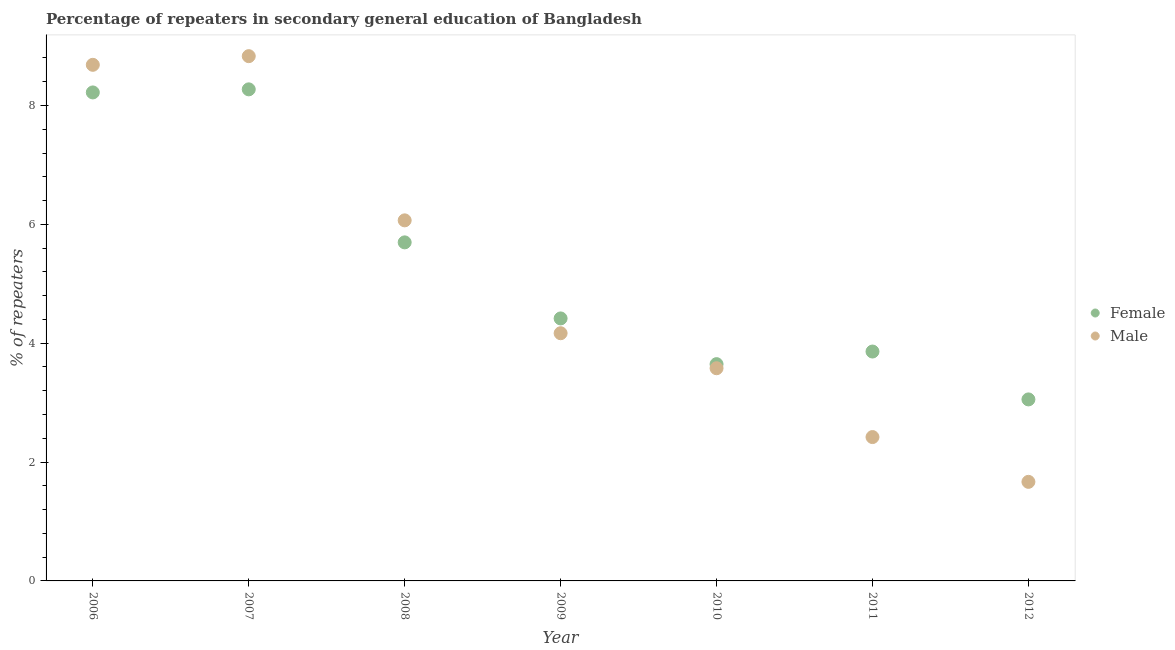What is the percentage of male repeaters in 2006?
Give a very brief answer. 8.68. Across all years, what is the maximum percentage of female repeaters?
Provide a succinct answer. 8.27. Across all years, what is the minimum percentage of female repeaters?
Offer a terse response. 3.05. In which year was the percentage of female repeaters minimum?
Make the answer very short. 2012. What is the total percentage of female repeaters in the graph?
Offer a terse response. 37.17. What is the difference between the percentage of male repeaters in 2007 and that in 2008?
Your answer should be very brief. 2.76. What is the difference between the percentage of male repeaters in 2010 and the percentage of female repeaters in 2008?
Offer a terse response. -2.12. What is the average percentage of male repeaters per year?
Your answer should be very brief. 5.06. In the year 2010, what is the difference between the percentage of female repeaters and percentage of male repeaters?
Your response must be concise. 0.07. In how many years, is the percentage of female repeaters greater than 4.8 %?
Your answer should be very brief. 3. What is the ratio of the percentage of female repeaters in 2007 to that in 2009?
Offer a very short reply. 1.87. Is the percentage of male repeaters in 2007 less than that in 2008?
Keep it short and to the point. No. What is the difference between the highest and the second highest percentage of male repeaters?
Your response must be concise. 0.15. What is the difference between the highest and the lowest percentage of male repeaters?
Your answer should be very brief. 7.16. In how many years, is the percentage of male repeaters greater than the average percentage of male repeaters taken over all years?
Your response must be concise. 3. How many years are there in the graph?
Ensure brevity in your answer.  7. What is the difference between two consecutive major ticks on the Y-axis?
Provide a succinct answer. 2. Are the values on the major ticks of Y-axis written in scientific E-notation?
Your answer should be compact. No. Does the graph contain grids?
Ensure brevity in your answer.  No. How many legend labels are there?
Offer a very short reply. 2. What is the title of the graph?
Make the answer very short. Percentage of repeaters in secondary general education of Bangladesh. What is the label or title of the Y-axis?
Make the answer very short. % of repeaters. What is the % of repeaters in Female in 2006?
Your response must be concise. 8.22. What is the % of repeaters in Male in 2006?
Provide a succinct answer. 8.68. What is the % of repeaters of Female in 2007?
Provide a short and direct response. 8.27. What is the % of repeaters of Male in 2007?
Ensure brevity in your answer.  8.83. What is the % of repeaters in Female in 2008?
Keep it short and to the point. 5.7. What is the % of repeaters in Male in 2008?
Ensure brevity in your answer.  6.07. What is the % of repeaters in Female in 2009?
Your answer should be compact. 4.42. What is the % of repeaters of Male in 2009?
Provide a succinct answer. 4.17. What is the % of repeaters of Female in 2010?
Make the answer very short. 3.65. What is the % of repeaters in Male in 2010?
Offer a terse response. 3.58. What is the % of repeaters of Female in 2011?
Keep it short and to the point. 3.86. What is the % of repeaters of Male in 2011?
Your answer should be compact. 2.42. What is the % of repeaters in Female in 2012?
Your answer should be very brief. 3.05. What is the % of repeaters of Male in 2012?
Ensure brevity in your answer.  1.67. Across all years, what is the maximum % of repeaters in Female?
Provide a short and direct response. 8.27. Across all years, what is the maximum % of repeaters in Male?
Your answer should be very brief. 8.83. Across all years, what is the minimum % of repeaters of Female?
Ensure brevity in your answer.  3.05. Across all years, what is the minimum % of repeaters in Male?
Your answer should be very brief. 1.67. What is the total % of repeaters in Female in the graph?
Provide a succinct answer. 37.17. What is the total % of repeaters of Male in the graph?
Give a very brief answer. 35.41. What is the difference between the % of repeaters in Female in 2006 and that in 2007?
Keep it short and to the point. -0.05. What is the difference between the % of repeaters in Male in 2006 and that in 2007?
Offer a terse response. -0.15. What is the difference between the % of repeaters in Female in 2006 and that in 2008?
Make the answer very short. 2.52. What is the difference between the % of repeaters of Male in 2006 and that in 2008?
Provide a succinct answer. 2.62. What is the difference between the % of repeaters in Female in 2006 and that in 2009?
Your response must be concise. 3.8. What is the difference between the % of repeaters in Male in 2006 and that in 2009?
Give a very brief answer. 4.52. What is the difference between the % of repeaters of Female in 2006 and that in 2010?
Your response must be concise. 4.57. What is the difference between the % of repeaters of Male in 2006 and that in 2010?
Keep it short and to the point. 5.11. What is the difference between the % of repeaters in Female in 2006 and that in 2011?
Provide a short and direct response. 4.36. What is the difference between the % of repeaters in Male in 2006 and that in 2011?
Offer a terse response. 6.26. What is the difference between the % of repeaters in Female in 2006 and that in 2012?
Provide a succinct answer. 5.17. What is the difference between the % of repeaters in Male in 2006 and that in 2012?
Offer a terse response. 7.02. What is the difference between the % of repeaters in Female in 2007 and that in 2008?
Give a very brief answer. 2.57. What is the difference between the % of repeaters of Male in 2007 and that in 2008?
Ensure brevity in your answer.  2.76. What is the difference between the % of repeaters in Female in 2007 and that in 2009?
Make the answer very short. 3.85. What is the difference between the % of repeaters of Male in 2007 and that in 2009?
Your answer should be compact. 4.66. What is the difference between the % of repeaters in Female in 2007 and that in 2010?
Your response must be concise. 4.62. What is the difference between the % of repeaters of Male in 2007 and that in 2010?
Ensure brevity in your answer.  5.25. What is the difference between the % of repeaters of Female in 2007 and that in 2011?
Provide a short and direct response. 4.41. What is the difference between the % of repeaters of Male in 2007 and that in 2011?
Offer a very short reply. 6.41. What is the difference between the % of repeaters of Female in 2007 and that in 2012?
Ensure brevity in your answer.  5.22. What is the difference between the % of repeaters in Male in 2007 and that in 2012?
Offer a very short reply. 7.16. What is the difference between the % of repeaters in Female in 2008 and that in 2009?
Your answer should be very brief. 1.28. What is the difference between the % of repeaters of Male in 2008 and that in 2009?
Provide a short and direct response. 1.9. What is the difference between the % of repeaters of Female in 2008 and that in 2010?
Provide a short and direct response. 2.05. What is the difference between the % of repeaters of Male in 2008 and that in 2010?
Provide a short and direct response. 2.49. What is the difference between the % of repeaters in Female in 2008 and that in 2011?
Give a very brief answer. 1.84. What is the difference between the % of repeaters in Male in 2008 and that in 2011?
Provide a succinct answer. 3.65. What is the difference between the % of repeaters in Female in 2008 and that in 2012?
Provide a short and direct response. 2.64. What is the difference between the % of repeaters of Male in 2008 and that in 2012?
Your answer should be very brief. 4.4. What is the difference between the % of repeaters of Female in 2009 and that in 2010?
Your answer should be compact. 0.77. What is the difference between the % of repeaters of Male in 2009 and that in 2010?
Your answer should be very brief. 0.59. What is the difference between the % of repeaters in Female in 2009 and that in 2011?
Your answer should be compact. 0.56. What is the difference between the % of repeaters in Male in 2009 and that in 2011?
Provide a short and direct response. 1.75. What is the difference between the % of repeaters of Female in 2009 and that in 2012?
Provide a succinct answer. 1.36. What is the difference between the % of repeaters of Male in 2009 and that in 2012?
Offer a very short reply. 2.5. What is the difference between the % of repeaters in Female in 2010 and that in 2011?
Provide a short and direct response. -0.21. What is the difference between the % of repeaters of Male in 2010 and that in 2011?
Provide a succinct answer. 1.16. What is the difference between the % of repeaters in Female in 2010 and that in 2012?
Provide a succinct answer. 0.59. What is the difference between the % of repeaters in Male in 2010 and that in 2012?
Offer a very short reply. 1.91. What is the difference between the % of repeaters in Female in 2011 and that in 2012?
Provide a short and direct response. 0.81. What is the difference between the % of repeaters of Male in 2011 and that in 2012?
Provide a short and direct response. 0.75. What is the difference between the % of repeaters in Female in 2006 and the % of repeaters in Male in 2007?
Keep it short and to the point. -0.61. What is the difference between the % of repeaters in Female in 2006 and the % of repeaters in Male in 2008?
Give a very brief answer. 2.15. What is the difference between the % of repeaters of Female in 2006 and the % of repeaters of Male in 2009?
Keep it short and to the point. 4.05. What is the difference between the % of repeaters in Female in 2006 and the % of repeaters in Male in 2010?
Your answer should be very brief. 4.64. What is the difference between the % of repeaters in Female in 2006 and the % of repeaters in Male in 2011?
Keep it short and to the point. 5.8. What is the difference between the % of repeaters of Female in 2006 and the % of repeaters of Male in 2012?
Ensure brevity in your answer.  6.55. What is the difference between the % of repeaters of Female in 2007 and the % of repeaters of Male in 2008?
Ensure brevity in your answer.  2.2. What is the difference between the % of repeaters of Female in 2007 and the % of repeaters of Male in 2009?
Offer a very short reply. 4.1. What is the difference between the % of repeaters of Female in 2007 and the % of repeaters of Male in 2010?
Give a very brief answer. 4.69. What is the difference between the % of repeaters in Female in 2007 and the % of repeaters in Male in 2011?
Provide a succinct answer. 5.85. What is the difference between the % of repeaters of Female in 2007 and the % of repeaters of Male in 2012?
Your answer should be very brief. 6.6. What is the difference between the % of repeaters of Female in 2008 and the % of repeaters of Male in 2009?
Give a very brief answer. 1.53. What is the difference between the % of repeaters of Female in 2008 and the % of repeaters of Male in 2010?
Provide a short and direct response. 2.12. What is the difference between the % of repeaters in Female in 2008 and the % of repeaters in Male in 2011?
Make the answer very short. 3.28. What is the difference between the % of repeaters in Female in 2008 and the % of repeaters in Male in 2012?
Provide a short and direct response. 4.03. What is the difference between the % of repeaters in Female in 2009 and the % of repeaters in Male in 2010?
Provide a succinct answer. 0.84. What is the difference between the % of repeaters of Female in 2009 and the % of repeaters of Male in 2011?
Provide a short and direct response. 2. What is the difference between the % of repeaters of Female in 2009 and the % of repeaters of Male in 2012?
Your answer should be very brief. 2.75. What is the difference between the % of repeaters in Female in 2010 and the % of repeaters in Male in 2011?
Your response must be concise. 1.23. What is the difference between the % of repeaters of Female in 2010 and the % of repeaters of Male in 2012?
Make the answer very short. 1.98. What is the difference between the % of repeaters of Female in 2011 and the % of repeaters of Male in 2012?
Your answer should be compact. 2.19. What is the average % of repeaters in Female per year?
Ensure brevity in your answer.  5.31. What is the average % of repeaters in Male per year?
Keep it short and to the point. 5.06. In the year 2006, what is the difference between the % of repeaters of Female and % of repeaters of Male?
Your answer should be compact. -0.46. In the year 2007, what is the difference between the % of repeaters in Female and % of repeaters in Male?
Keep it short and to the point. -0.56. In the year 2008, what is the difference between the % of repeaters of Female and % of repeaters of Male?
Give a very brief answer. -0.37. In the year 2009, what is the difference between the % of repeaters in Female and % of repeaters in Male?
Give a very brief answer. 0.25. In the year 2010, what is the difference between the % of repeaters in Female and % of repeaters in Male?
Give a very brief answer. 0.07. In the year 2011, what is the difference between the % of repeaters of Female and % of repeaters of Male?
Provide a short and direct response. 1.44. In the year 2012, what is the difference between the % of repeaters in Female and % of repeaters in Male?
Keep it short and to the point. 1.39. What is the ratio of the % of repeaters in Female in 2006 to that in 2007?
Your response must be concise. 0.99. What is the ratio of the % of repeaters in Male in 2006 to that in 2007?
Ensure brevity in your answer.  0.98. What is the ratio of the % of repeaters of Female in 2006 to that in 2008?
Your response must be concise. 1.44. What is the ratio of the % of repeaters of Male in 2006 to that in 2008?
Offer a very short reply. 1.43. What is the ratio of the % of repeaters in Female in 2006 to that in 2009?
Your response must be concise. 1.86. What is the ratio of the % of repeaters of Male in 2006 to that in 2009?
Ensure brevity in your answer.  2.08. What is the ratio of the % of repeaters in Female in 2006 to that in 2010?
Your answer should be compact. 2.25. What is the ratio of the % of repeaters of Male in 2006 to that in 2010?
Offer a terse response. 2.43. What is the ratio of the % of repeaters of Female in 2006 to that in 2011?
Keep it short and to the point. 2.13. What is the ratio of the % of repeaters of Male in 2006 to that in 2011?
Keep it short and to the point. 3.59. What is the ratio of the % of repeaters of Female in 2006 to that in 2012?
Your response must be concise. 2.69. What is the ratio of the % of repeaters in Male in 2006 to that in 2012?
Your response must be concise. 5.21. What is the ratio of the % of repeaters in Female in 2007 to that in 2008?
Offer a very short reply. 1.45. What is the ratio of the % of repeaters in Male in 2007 to that in 2008?
Your response must be concise. 1.46. What is the ratio of the % of repeaters in Female in 2007 to that in 2009?
Offer a terse response. 1.87. What is the ratio of the % of repeaters in Male in 2007 to that in 2009?
Ensure brevity in your answer.  2.12. What is the ratio of the % of repeaters of Female in 2007 to that in 2010?
Make the answer very short. 2.27. What is the ratio of the % of repeaters of Male in 2007 to that in 2010?
Ensure brevity in your answer.  2.47. What is the ratio of the % of repeaters of Female in 2007 to that in 2011?
Offer a very short reply. 2.14. What is the ratio of the % of repeaters of Male in 2007 to that in 2011?
Provide a succinct answer. 3.65. What is the ratio of the % of repeaters in Female in 2007 to that in 2012?
Provide a short and direct response. 2.71. What is the ratio of the % of repeaters of Male in 2007 to that in 2012?
Give a very brief answer. 5.3. What is the ratio of the % of repeaters of Female in 2008 to that in 2009?
Offer a terse response. 1.29. What is the ratio of the % of repeaters of Male in 2008 to that in 2009?
Make the answer very short. 1.46. What is the ratio of the % of repeaters of Female in 2008 to that in 2010?
Offer a very short reply. 1.56. What is the ratio of the % of repeaters of Male in 2008 to that in 2010?
Keep it short and to the point. 1.7. What is the ratio of the % of repeaters in Female in 2008 to that in 2011?
Provide a short and direct response. 1.48. What is the ratio of the % of repeaters of Male in 2008 to that in 2011?
Provide a succinct answer. 2.51. What is the ratio of the % of repeaters of Female in 2008 to that in 2012?
Your answer should be very brief. 1.87. What is the ratio of the % of repeaters in Male in 2008 to that in 2012?
Your response must be concise. 3.64. What is the ratio of the % of repeaters in Female in 2009 to that in 2010?
Offer a terse response. 1.21. What is the ratio of the % of repeaters in Male in 2009 to that in 2010?
Offer a very short reply. 1.16. What is the ratio of the % of repeaters of Female in 2009 to that in 2011?
Your answer should be compact. 1.14. What is the ratio of the % of repeaters in Male in 2009 to that in 2011?
Provide a short and direct response. 1.72. What is the ratio of the % of repeaters in Female in 2009 to that in 2012?
Your answer should be very brief. 1.45. What is the ratio of the % of repeaters of Male in 2009 to that in 2012?
Your answer should be very brief. 2.5. What is the ratio of the % of repeaters in Female in 2010 to that in 2011?
Give a very brief answer. 0.94. What is the ratio of the % of repeaters of Male in 2010 to that in 2011?
Your answer should be very brief. 1.48. What is the ratio of the % of repeaters of Female in 2010 to that in 2012?
Give a very brief answer. 1.19. What is the ratio of the % of repeaters of Male in 2010 to that in 2012?
Your answer should be compact. 2.15. What is the ratio of the % of repeaters in Female in 2011 to that in 2012?
Your answer should be compact. 1.26. What is the ratio of the % of repeaters in Male in 2011 to that in 2012?
Give a very brief answer. 1.45. What is the difference between the highest and the second highest % of repeaters in Female?
Your answer should be very brief. 0.05. What is the difference between the highest and the second highest % of repeaters of Male?
Ensure brevity in your answer.  0.15. What is the difference between the highest and the lowest % of repeaters in Female?
Your answer should be very brief. 5.22. What is the difference between the highest and the lowest % of repeaters in Male?
Ensure brevity in your answer.  7.16. 